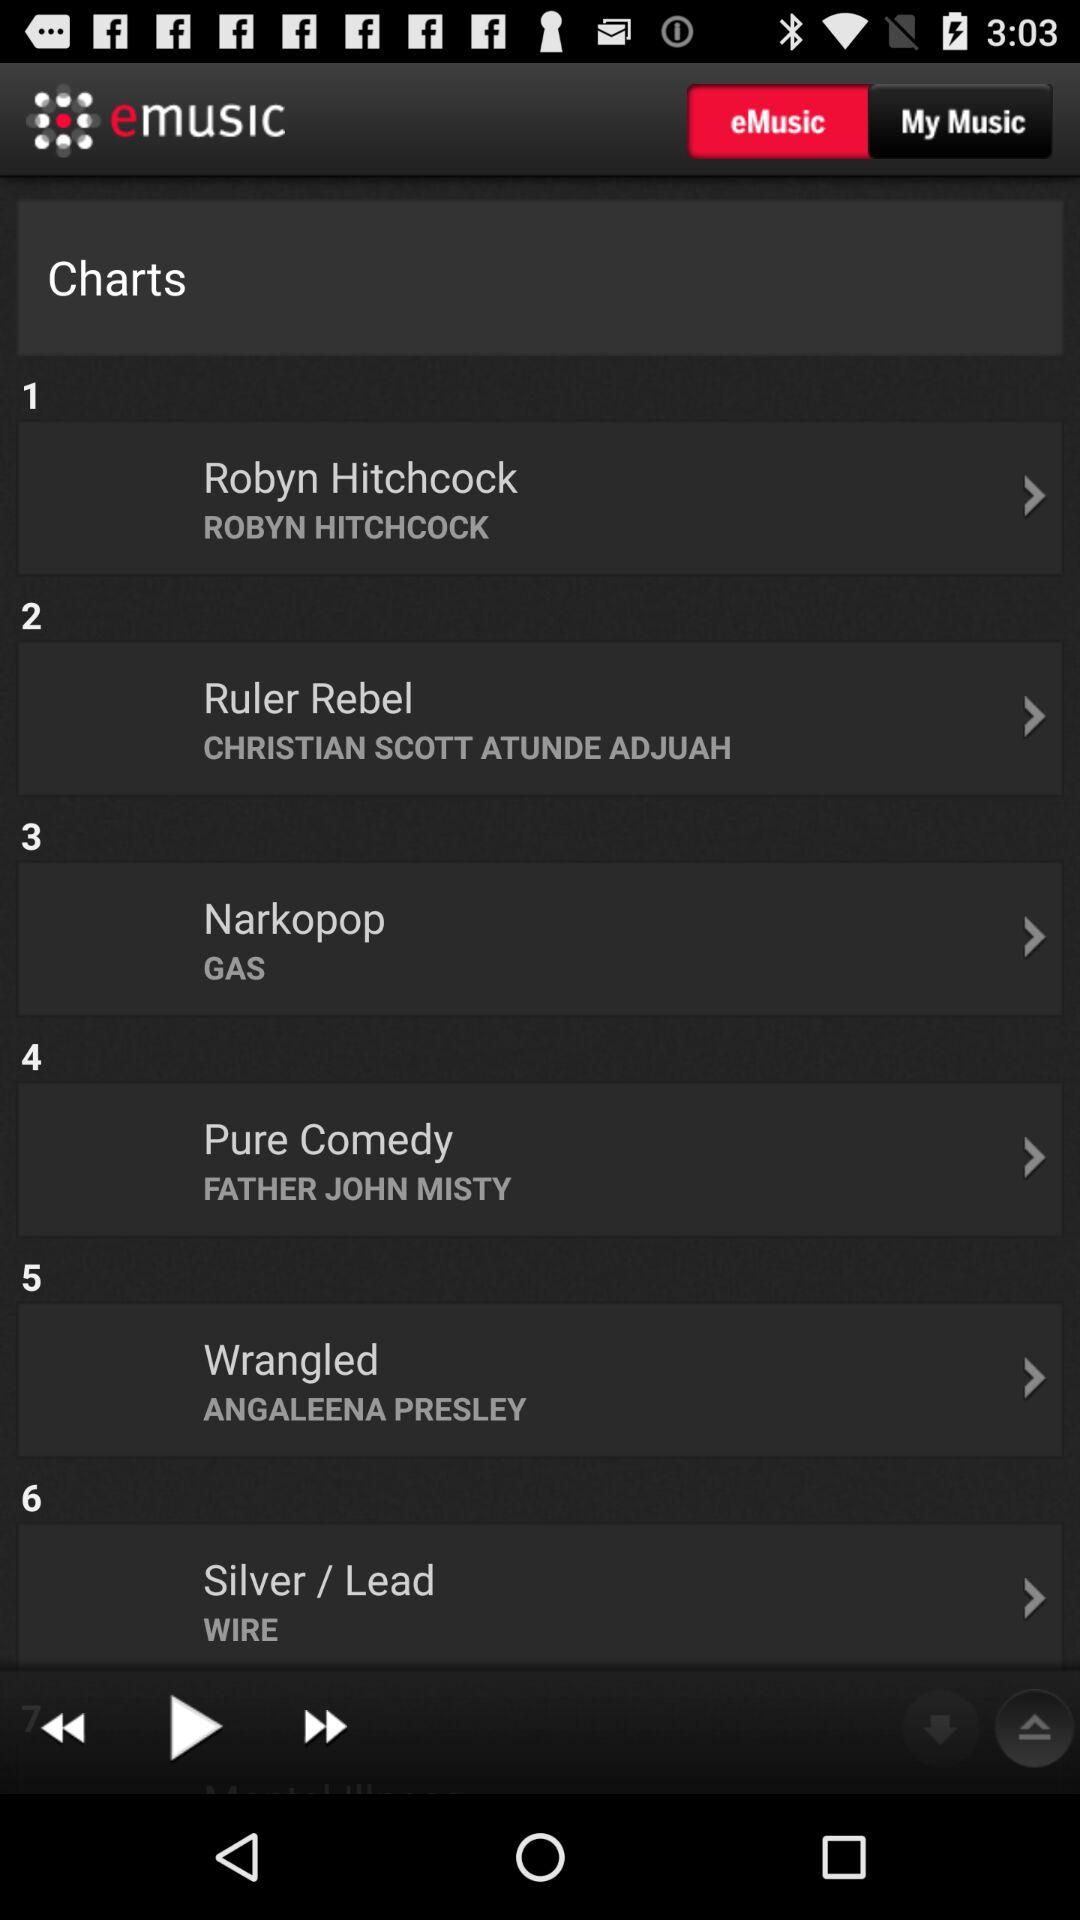What is the name of the application? The name of the application is "emusic". 